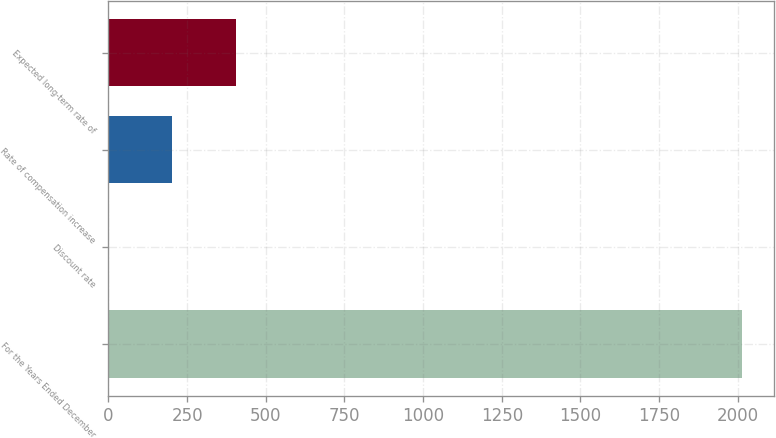Convert chart. <chart><loc_0><loc_0><loc_500><loc_500><bar_chart><fcel>For the Years Ended December<fcel>Discount rate<fcel>Rate of compensation increase<fcel>Expected long-term rate of<nl><fcel>2013<fcel>2.13<fcel>203.22<fcel>404.31<nl></chart> 